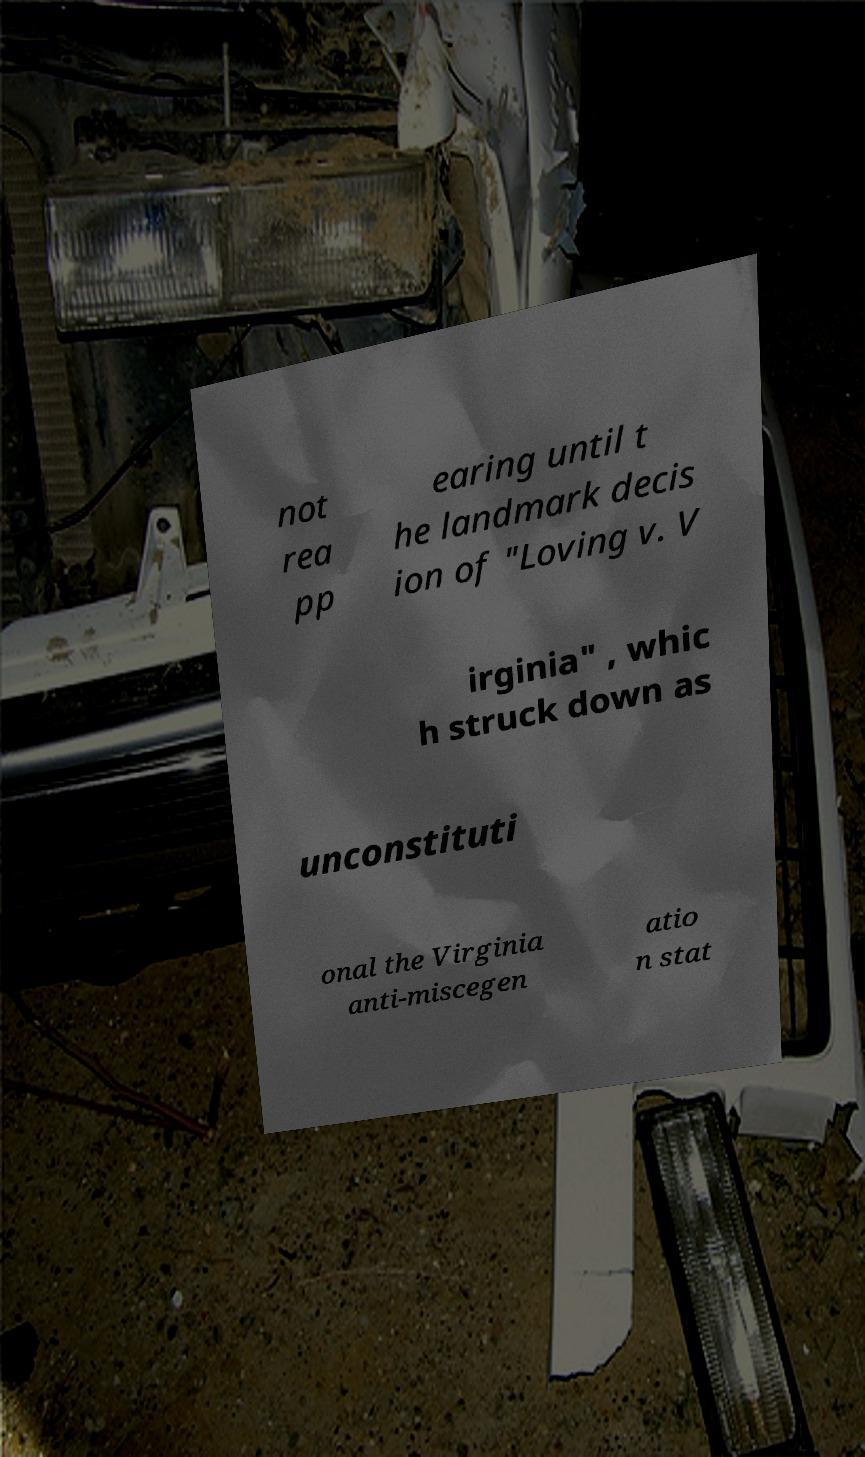There's text embedded in this image that I need extracted. Can you transcribe it verbatim? not rea pp earing until t he landmark decis ion of "Loving v. V irginia" , whic h struck down as unconstituti onal the Virginia anti-miscegen atio n stat 